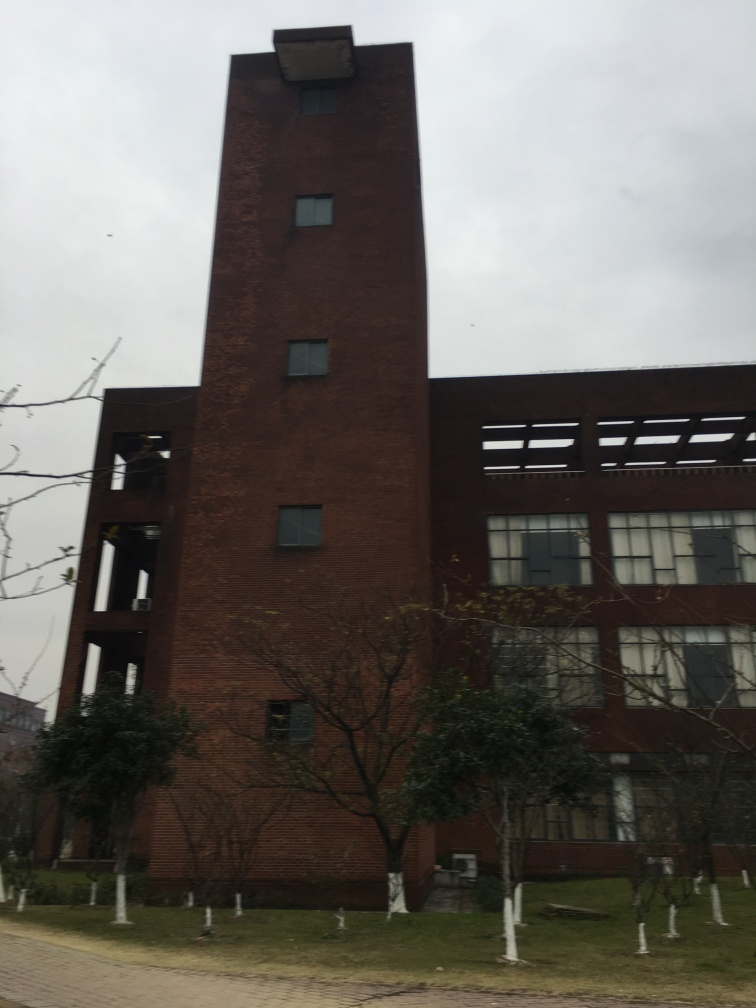Does this picture convey any specific mood or atmosphere? The photo has a somewhat somber and quiet atmosphere. The overcast sky, bare trees, and the stark appearance of the building give it a lonely, perhaps melancholic feel, which might be amplified by the absence of people or activity. 